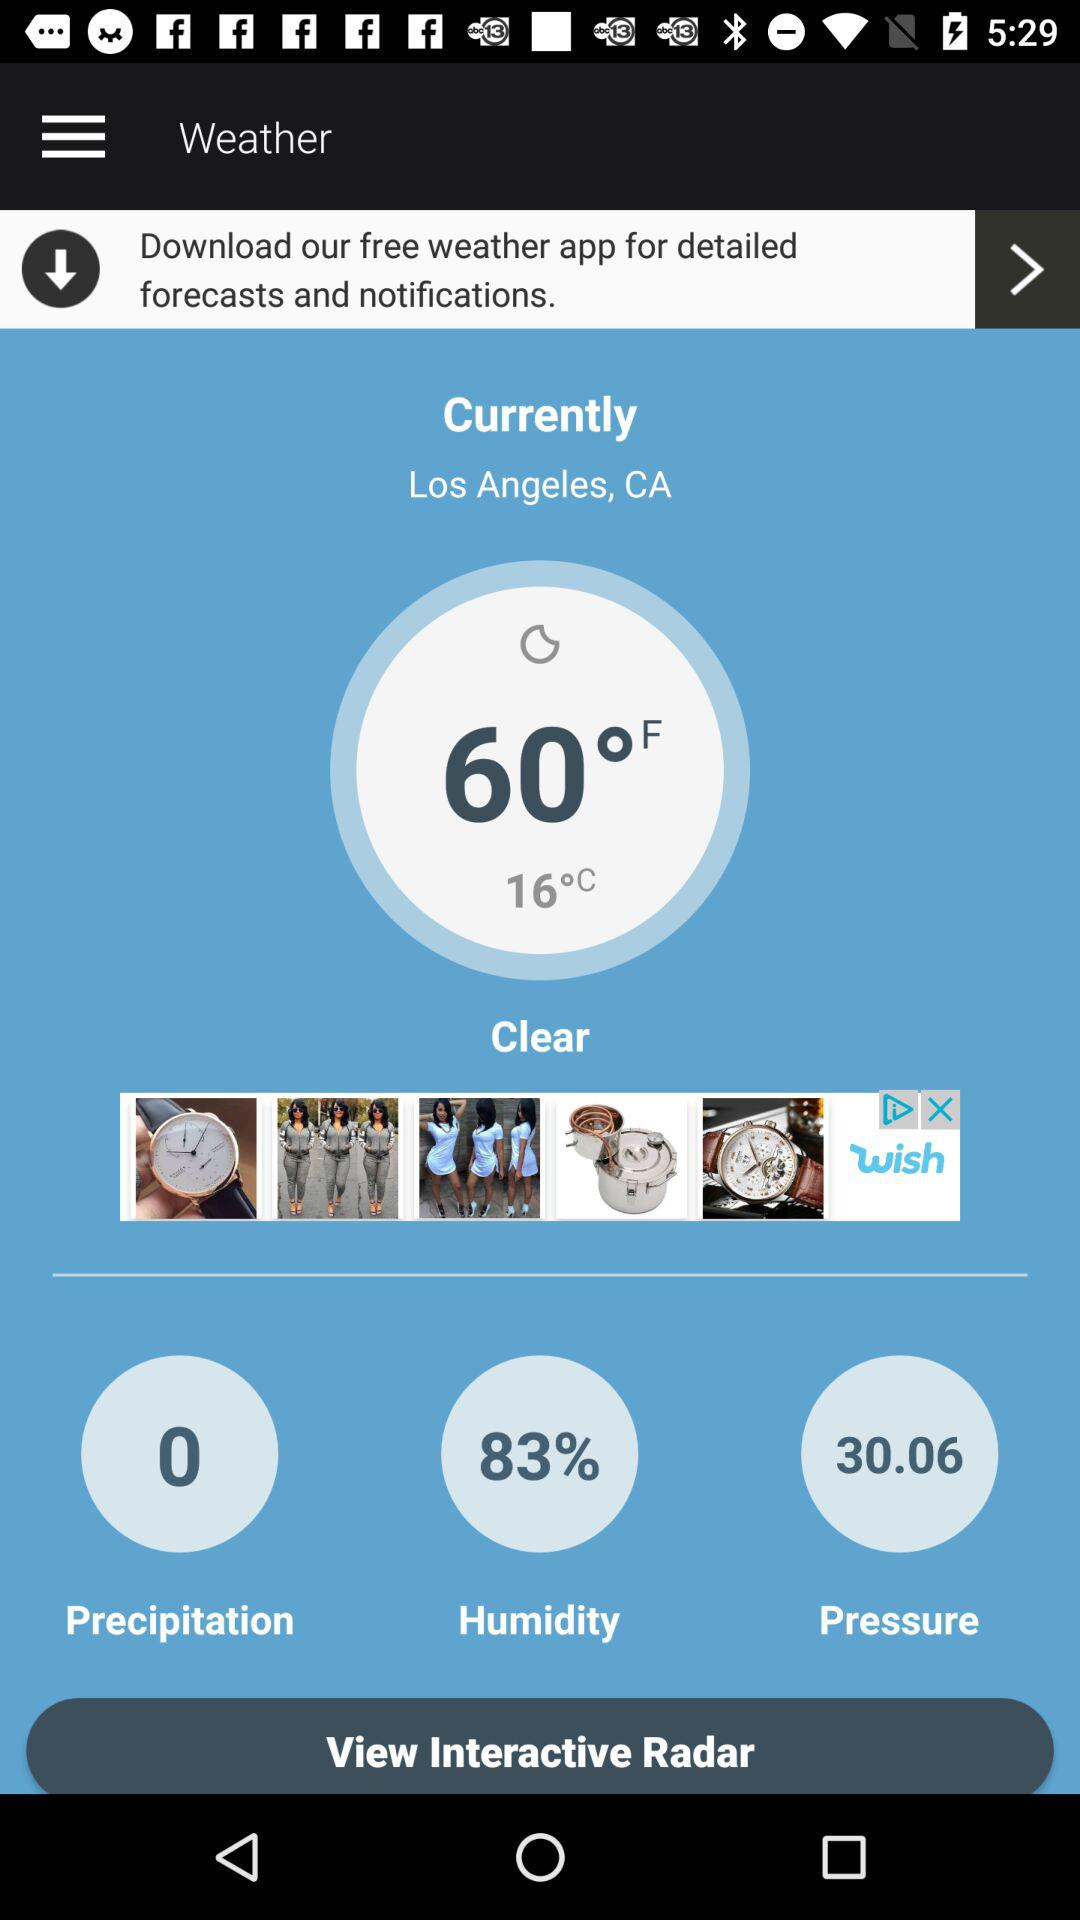What is the humidity percentage? The humidity percentage is 83%. 